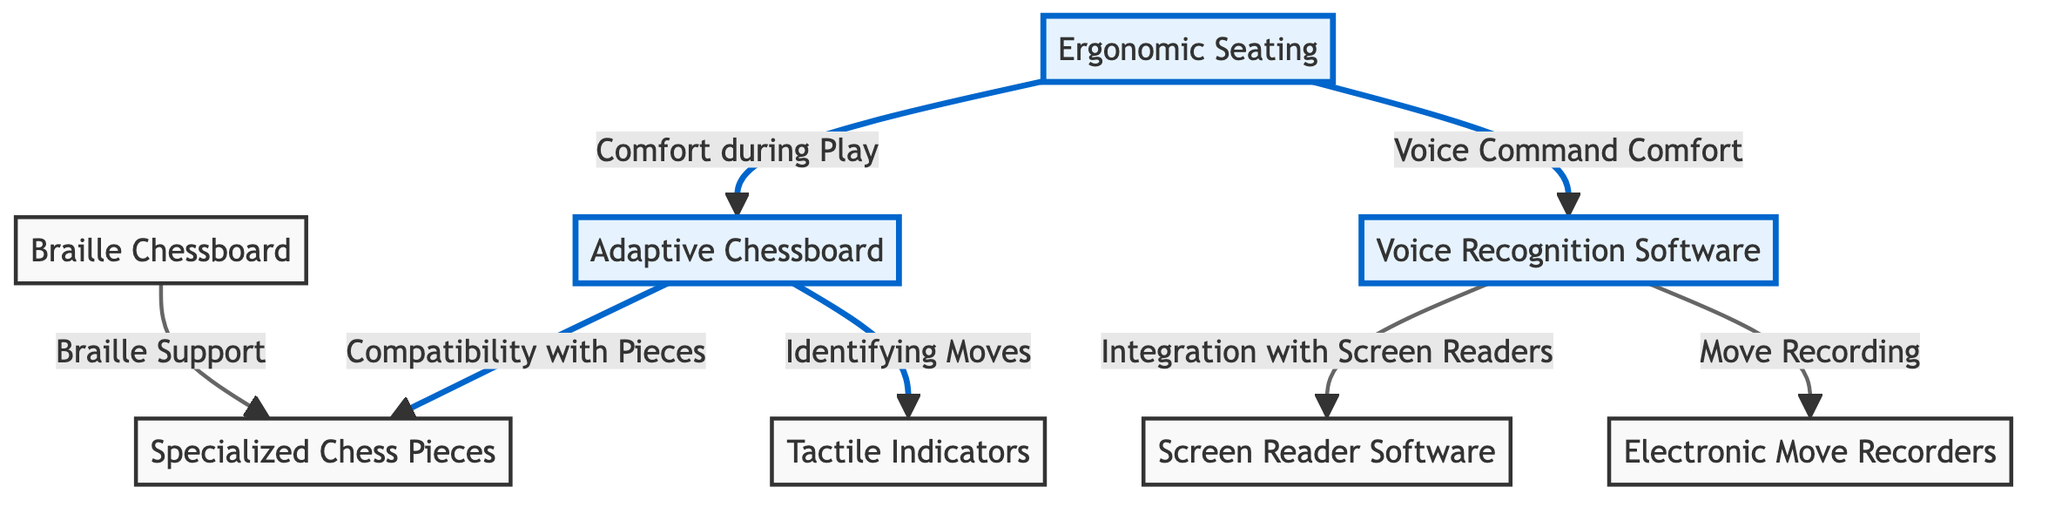What is the first node in the diagram? The first node in the diagram is labeled "Adaptive Chessboard". It is visually positioned at the top of the diagram and highlighted in blue.
Answer: Adaptive Chessboard How many main categories of adaptive chess tools are shown? There are seven nodes displayed in the diagram,  which represent different adaptive chess tools. However, there are three highlighted nodes indicating main categories: Adaptive Chessboard, Voice Recognition Software, and Ergonomic Seating.
Answer: Three Which node is connected to the "Electronic Move Recorders"? The "Electronic Move Recorders" node is connected to the "Voice Recognition Software" node. The arrow indicates that the software facilitates the recording of moves.
Answer: Voice Recognition Software What does the "Tactile Indicators" node connect to? The "Tactile Indicators" node connects only to the "Adaptive Chessboard" node, indicating its role in identifying moves on the chessboard.
Answer: Adaptive Chessboard What is the relationship between "Ergonomic Seating" and "Adaptive Chessboard"? The relationship is indicated by an arrow stating "Comfort during Play". This suggests that ergonomic seating is designed to enhance comfort while using the adaptive chessboard.
Answer: Comfort during Play How does the "Voice Recognition Software" assist during chess play? The "Voice Recognition Software" assists through "Integration with Screen Readers" and "Move Recording". This indicates its dual function of providing accessibility and documenting gameplay.
Answer: Integration with Screen Readers, Move Recording Which node provides support specifically for the visually impaired? The "Braille Chessboard" provides support specifically for visually impaired players, as indicated by the label directly associated with it.
Answer: Braille Chessboard 